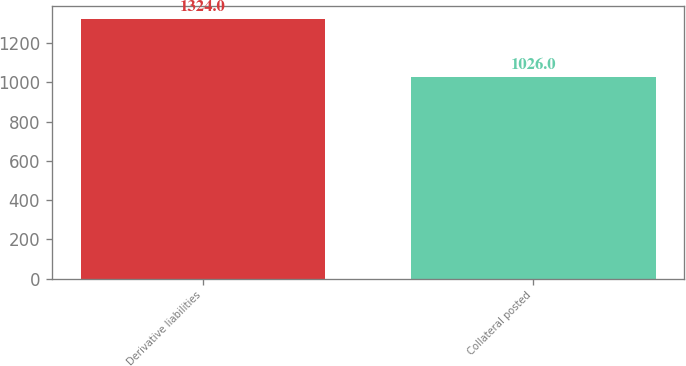Convert chart. <chart><loc_0><loc_0><loc_500><loc_500><bar_chart><fcel>Derivative liabilities<fcel>Collateral posted<nl><fcel>1324<fcel>1026<nl></chart> 